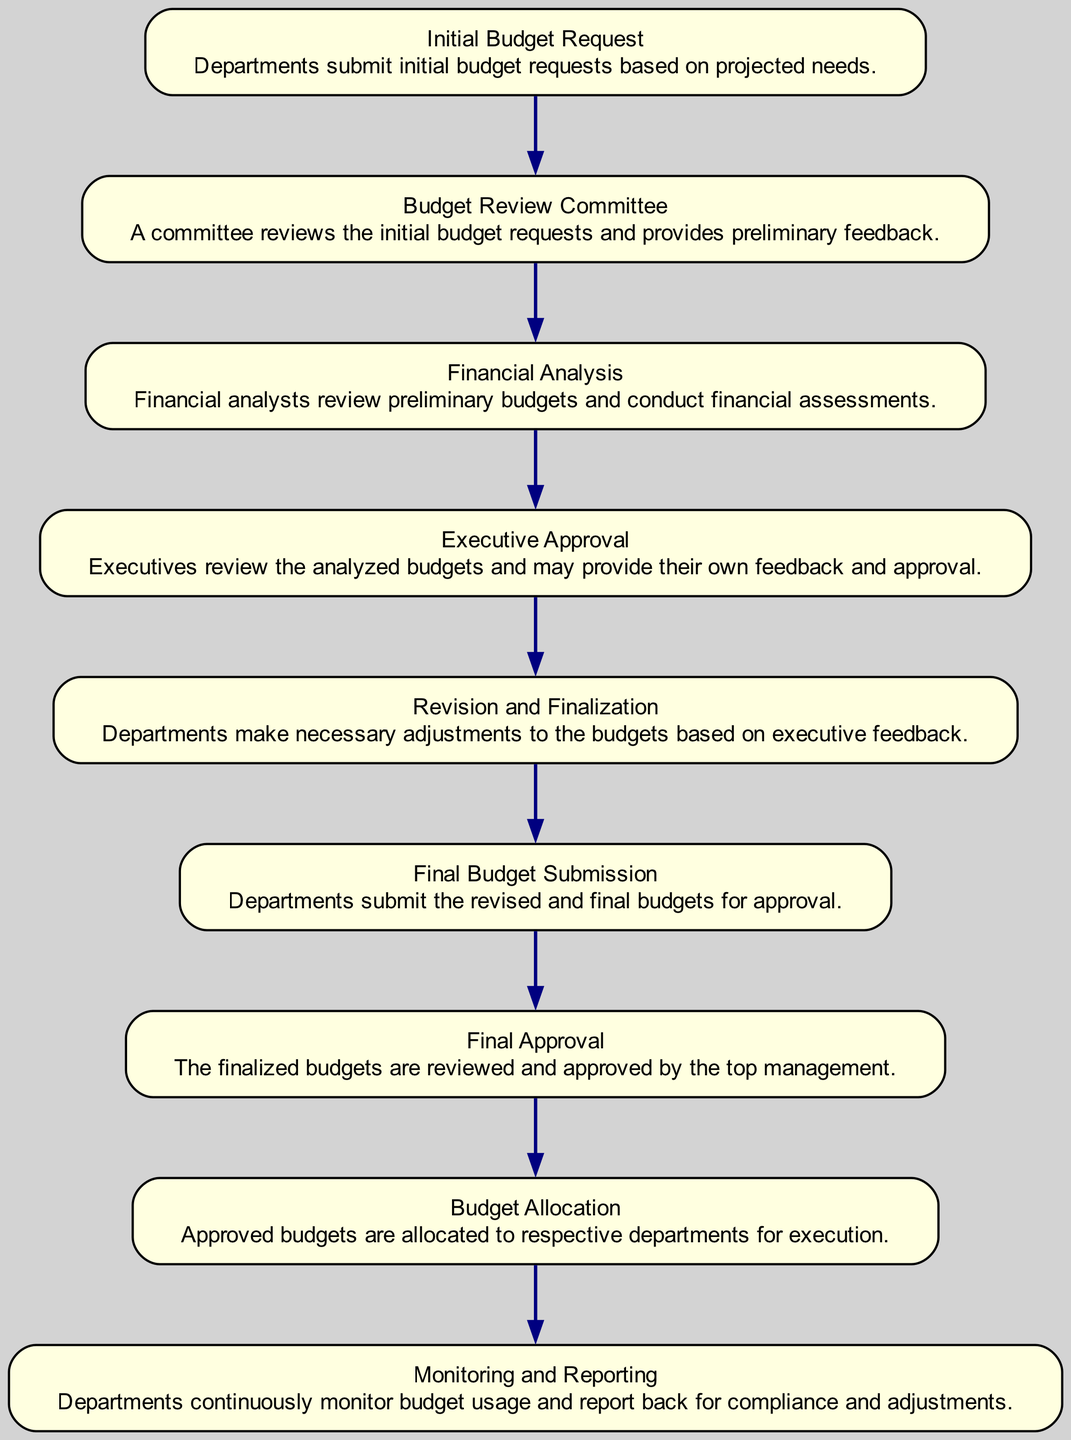What is the first step in the budget planning workflow? The first step listed in the diagram is "Initial Budget Request," where departments submit their initial budget requests based on projected needs.
Answer: Initial Budget Request How many nodes are present in the diagram? By counting each unique element represented in the diagram, there are a total of nine nodes.
Answer: 9 Which node receives feedback from the Budget Review Committee? The node that receives feedback from the Budget Review Committee is "Financial Analysis," as it directly depends on the budget review conducted by the committee.
Answer: Financial Analysis What is the final step of the budget allocation process? The last step in the workflow is "Monitoring and Reporting," where departments monitor budget usage and report compliance and adjustments.
Answer: Monitoring and Reporting Which element follows "Executive Approval" in the workflow? The element that follows "Executive Approval" is "Revision and Finalization," indicating that departments make necessary adjustments based on the feedback given.
Answer: Revision and Finalization How many dependencies does "Final Approval" have? Analyzing the diagram, "Final Approval" has one dependency, which is "Final Budget Submission."
Answer: 1 Which node is responsible for the final approval of budgets? The node responsible for the final approval of budgets is "Final Approval," where the finalized budgets are reviewed and approved by top management.
Answer: Final Approval What happens after "Final Budget Submission"? After "Final Budget Submission," the process proceeds to "Final Approval," where top management reviews and approves the submitted budgets.
Answer: Final Approval What is the role of the Budget Review Committee? The role of the Budget Review Committee is to review the initial budget requests and provide preliminary feedback to the departments.
Answer: Review initial budget requests 